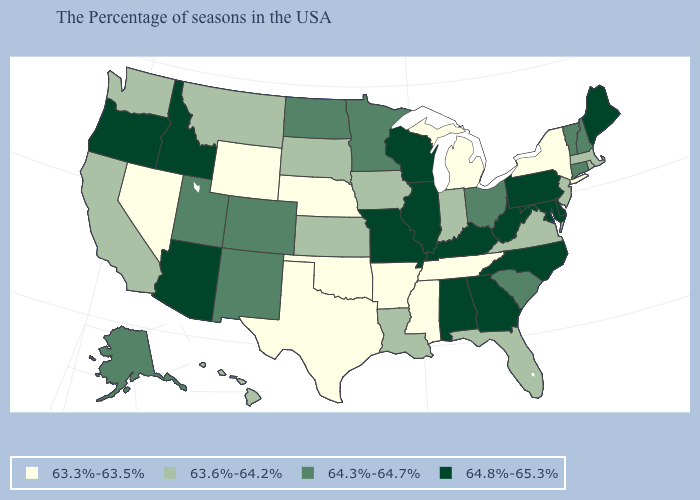Name the states that have a value in the range 63.6%-64.2%?
Concise answer only. Massachusetts, Rhode Island, New Jersey, Virginia, Florida, Indiana, Louisiana, Iowa, Kansas, South Dakota, Montana, California, Washington, Hawaii. Which states have the lowest value in the MidWest?
Quick response, please. Michigan, Nebraska. Is the legend a continuous bar?
Quick response, please. No. What is the value of Idaho?
Write a very short answer. 64.8%-65.3%. Name the states that have a value in the range 64.3%-64.7%?
Write a very short answer. New Hampshire, Vermont, Connecticut, South Carolina, Ohio, Minnesota, North Dakota, Colorado, New Mexico, Utah, Alaska. Does Pennsylvania have the same value as Kentucky?
Give a very brief answer. Yes. Name the states that have a value in the range 64.3%-64.7%?
Give a very brief answer. New Hampshire, Vermont, Connecticut, South Carolina, Ohio, Minnesota, North Dakota, Colorado, New Mexico, Utah, Alaska. What is the value of Arizona?
Write a very short answer. 64.8%-65.3%. How many symbols are there in the legend?
Give a very brief answer. 4. What is the value of Massachusetts?
Concise answer only. 63.6%-64.2%. What is the highest value in states that border Ohio?
Answer briefly. 64.8%-65.3%. What is the value of Georgia?
Give a very brief answer. 64.8%-65.3%. Name the states that have a value in the range 64.3%-64.7%?
Be succinct. New Hampshire, Vermont, Connecticut, South Carolina, Ohio, Minnesota, North Dakota, Colorado, New Mexico, Utah, Alaska. How many symbols are there in the legend?
Write a very short answer. 4. What is the value of Montana?
Keep it brief. 63.6%-64.2%. 